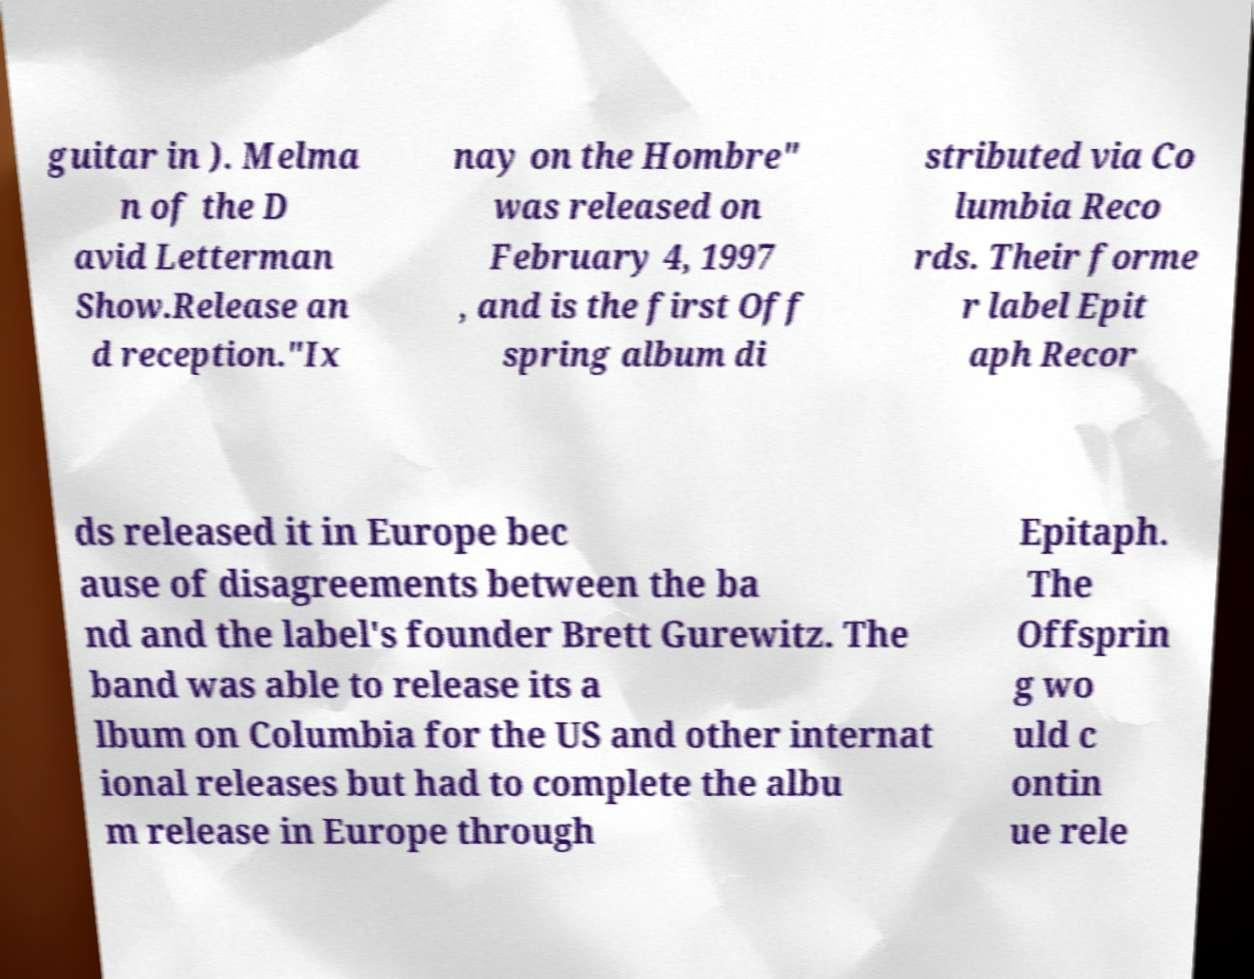Could you assist in decoding the text presented in this image and type it out clearly? guitar in ). Melma n of the D avid Letterman Show.Release an d reception."Ix nay on the Hombre" was released on February 4, 1997 , and is the first Off spring album di stributed via Co lumbia Reco rds. Their forme r label Epit aph Recor ds released it in Europe bec ause of disagreements between the ba nd and the label's founder Brett Gurewitz. The band was able to release its a lbum on Columbia for the US and other internat ional releases but had to complete the albu m release in Europe through Epitaph. The Offsprin g wo uld c ontin ue rele 